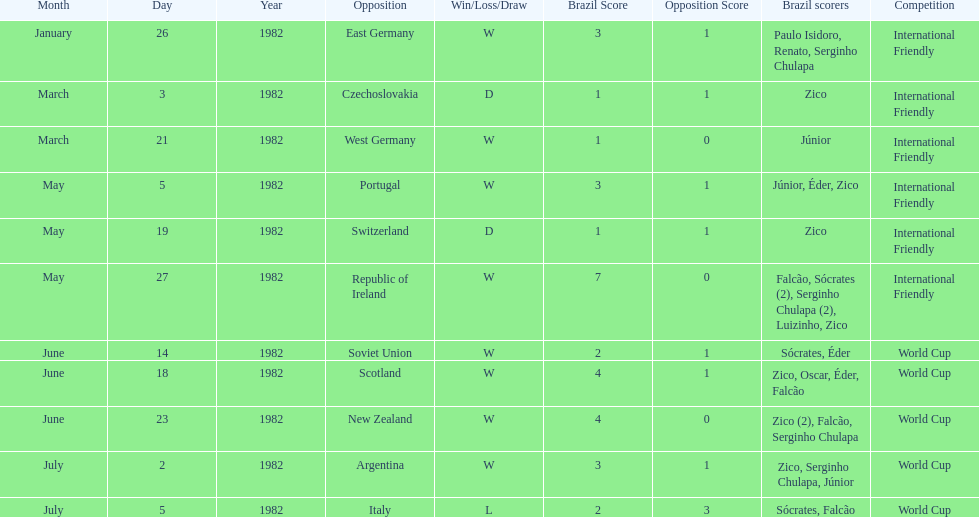Was the total goals scored on june 14, 1982 more than 6? No. 